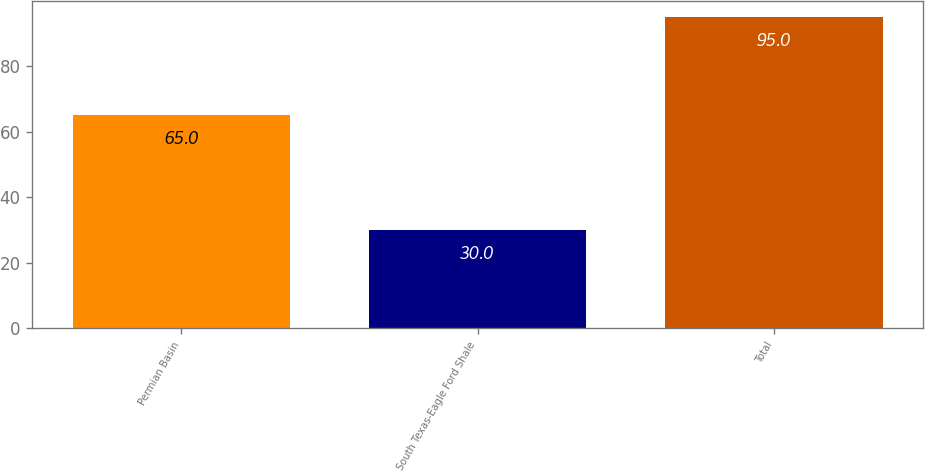Convert chart to OTSL. <chart><loc_0><loc_0><loc_500><loc_500><bar_chart><fcel>Permian Basin<fcel>South Texas-Eagle Ford Shale<fcel>Total<nl><fcel>65<fcel>30<fcel>95<nl></chart> 